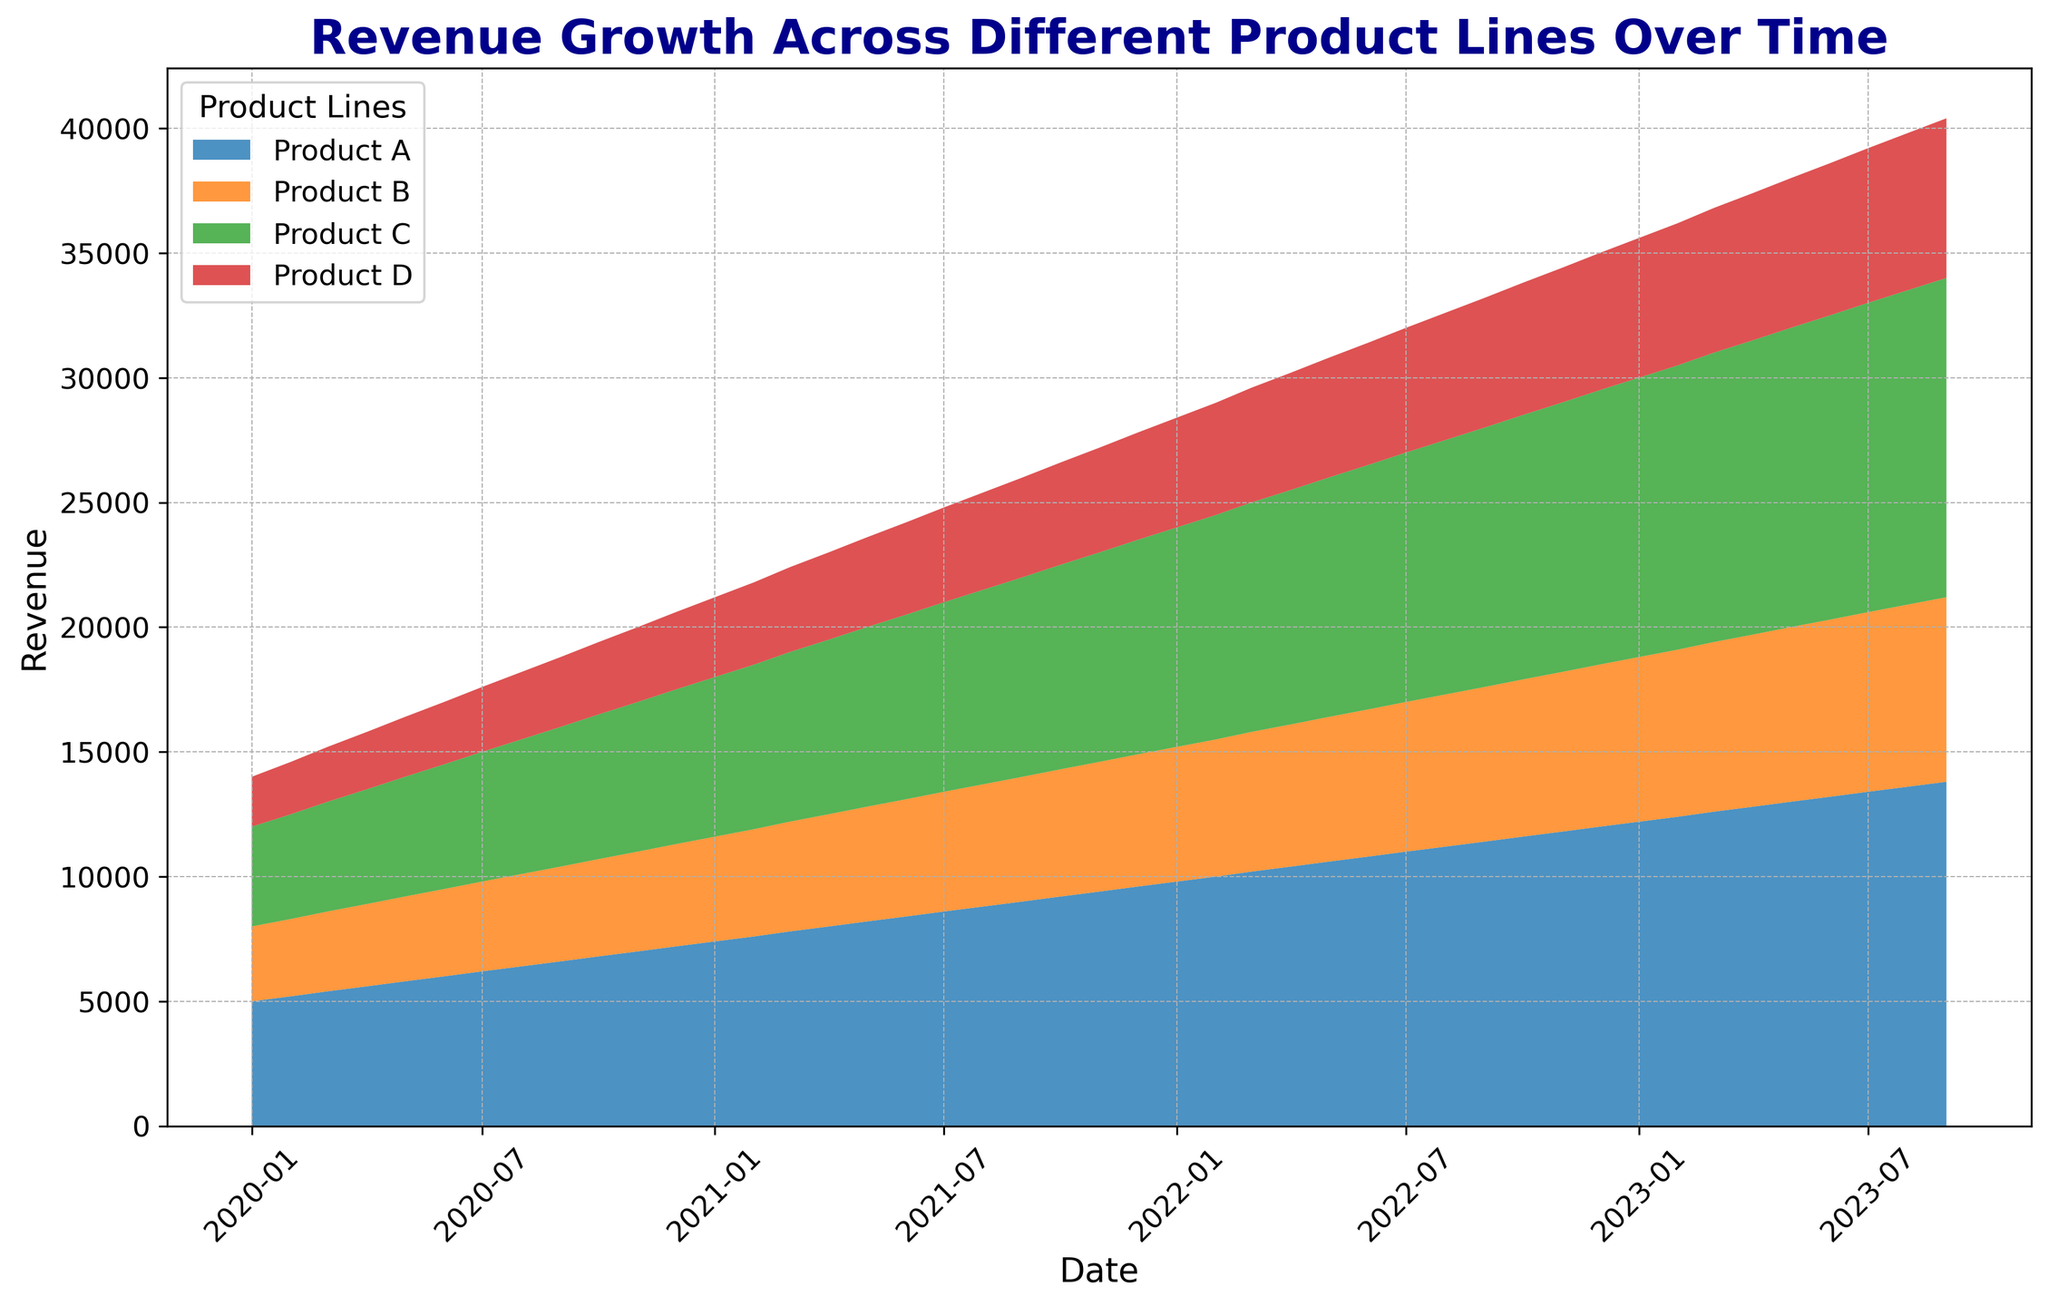What's the revenue difference between Product A and Product B in January 2020? To find the revenue difference, subtract the revenue of Product B from Product A in January 2020. Product A has 5000 and Product B has 3000, so the difference is 5000 - 3000.
Answer: 2000 Which product line shows the greatest increase in revenue from January 2020 to September 2023? Compare the revenues of all product lines in January 2020 and September 2023. Product A: from 5000 to 13800, Product B: from 3000 to 7400, Product C: from 4000 to 12800, and Product D: from 2000 to 6400. The greatest increase is Product C (12800-4000 = 8800).
Answer: Product C On average, which product had the least revenue over the period shown? Average the revenue for each product over all time periods. Product A, B, C, and D have consistent growth, but visually Product D has the lowest values overall.
Answer: Product D What is the cumulative revenue for all products in December 2022? Sum up the revenues of Products A (12000), B (6500), C (11000), and D (5500) in December 2022. The total is 12000 + 6500 + 11000 + 5500.
Answer: 35000 During which month(s) did all product lines experience simultaneous revenue growth compared to the previous month? For each month, check if the revenue for all products has increased from the previous month. This happens when each product's number in the current month is higher than in the previous month. The consistent growth rate suggests this occurs in every month throughout the given period.
Answer: Every month Is the proportion of Product B's revenue relative to the total revenue growing over time? Calculate the proportion of Product B's revenue to the total revenue for different months. Visually, the area for Product B is growing steadily, but not at a disproportionately higher rate compared to other products.
Answer: No How does the revenue trend for Product D compare visually to Product A over the entire period? Product D starts with the lowest revenue and continues to have the smallest values. Product A has the highest revenue and the largest area of growth. Product D's trend shows steady but smaller increments.
Answer: Product D grows slower What can you say about the growth pattern of Product C from start to finish? Product C starts at 4000 in January 2020 and ends at 12800 in September 2023. The increase appears to be consistently steady every month, indicating robust and regular growth.
Answer: Steady growth During which year did Product A see the most significant revenue growth? Compare the year-end revenues of Product A for each year. Product A's revenue at the end of 2020 is 7200, at the end of 2021 is 9600, at the end of 2022 is 12000, and in September 2023 it is 13800. The most significant growth is from 2020 to 2021 (2400 increase).
Answer: 2020 to 2021 For how long has Product B consistently increased its revenue each month? Product B's revenue increases each month continuously from January 2020 to September 2023, a consistent growth over the entire period of 45 months.
Answer: 45 months 